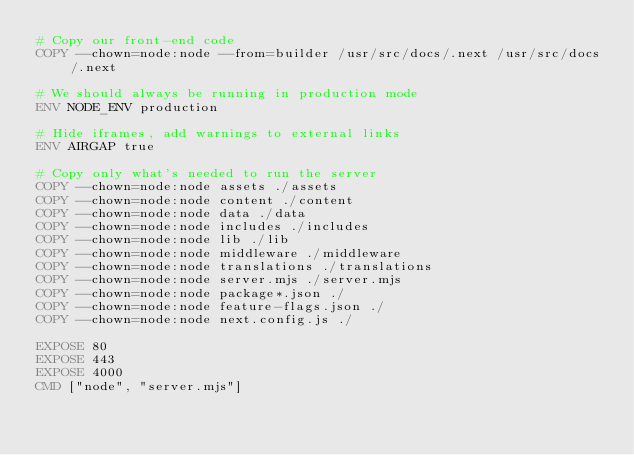<code> <loc_0><loc_0><loc_500><loc_500><_Dockerfile_># Copy our front-end code
COPY --chown=node:node --from=builder /usr/src/docs/.next /usr/src/docs/.next

# We should always be running in production mode
ENV NODE_ENV production

# Hide iframes, add warnings to external links
ENV AIRGAP true

# Copy only what's needed to run the server
COPY --chown=node:node assets ./assets
COPY --chown=node:node content ./content
COPY --chown=node:node data ./data
COPY --chown=node:node includes ./includes
COPY --chown=node:node lib ./lib
COPY --chown=node:node middleware ./middleware
COPY --chown=node:node translations ./translations
COPY --chown=node:node server.mjs ./server.mjs
COPY --chown=node:node package*.json ./
COPY --chown=node:node feature-flags.json ./
COPY --chown=node:node next.config.js ./

EXPOSE 80
EXPOSE 443
EXPOSE 4000
CMD ["node", "server.mjs"]
</code> 